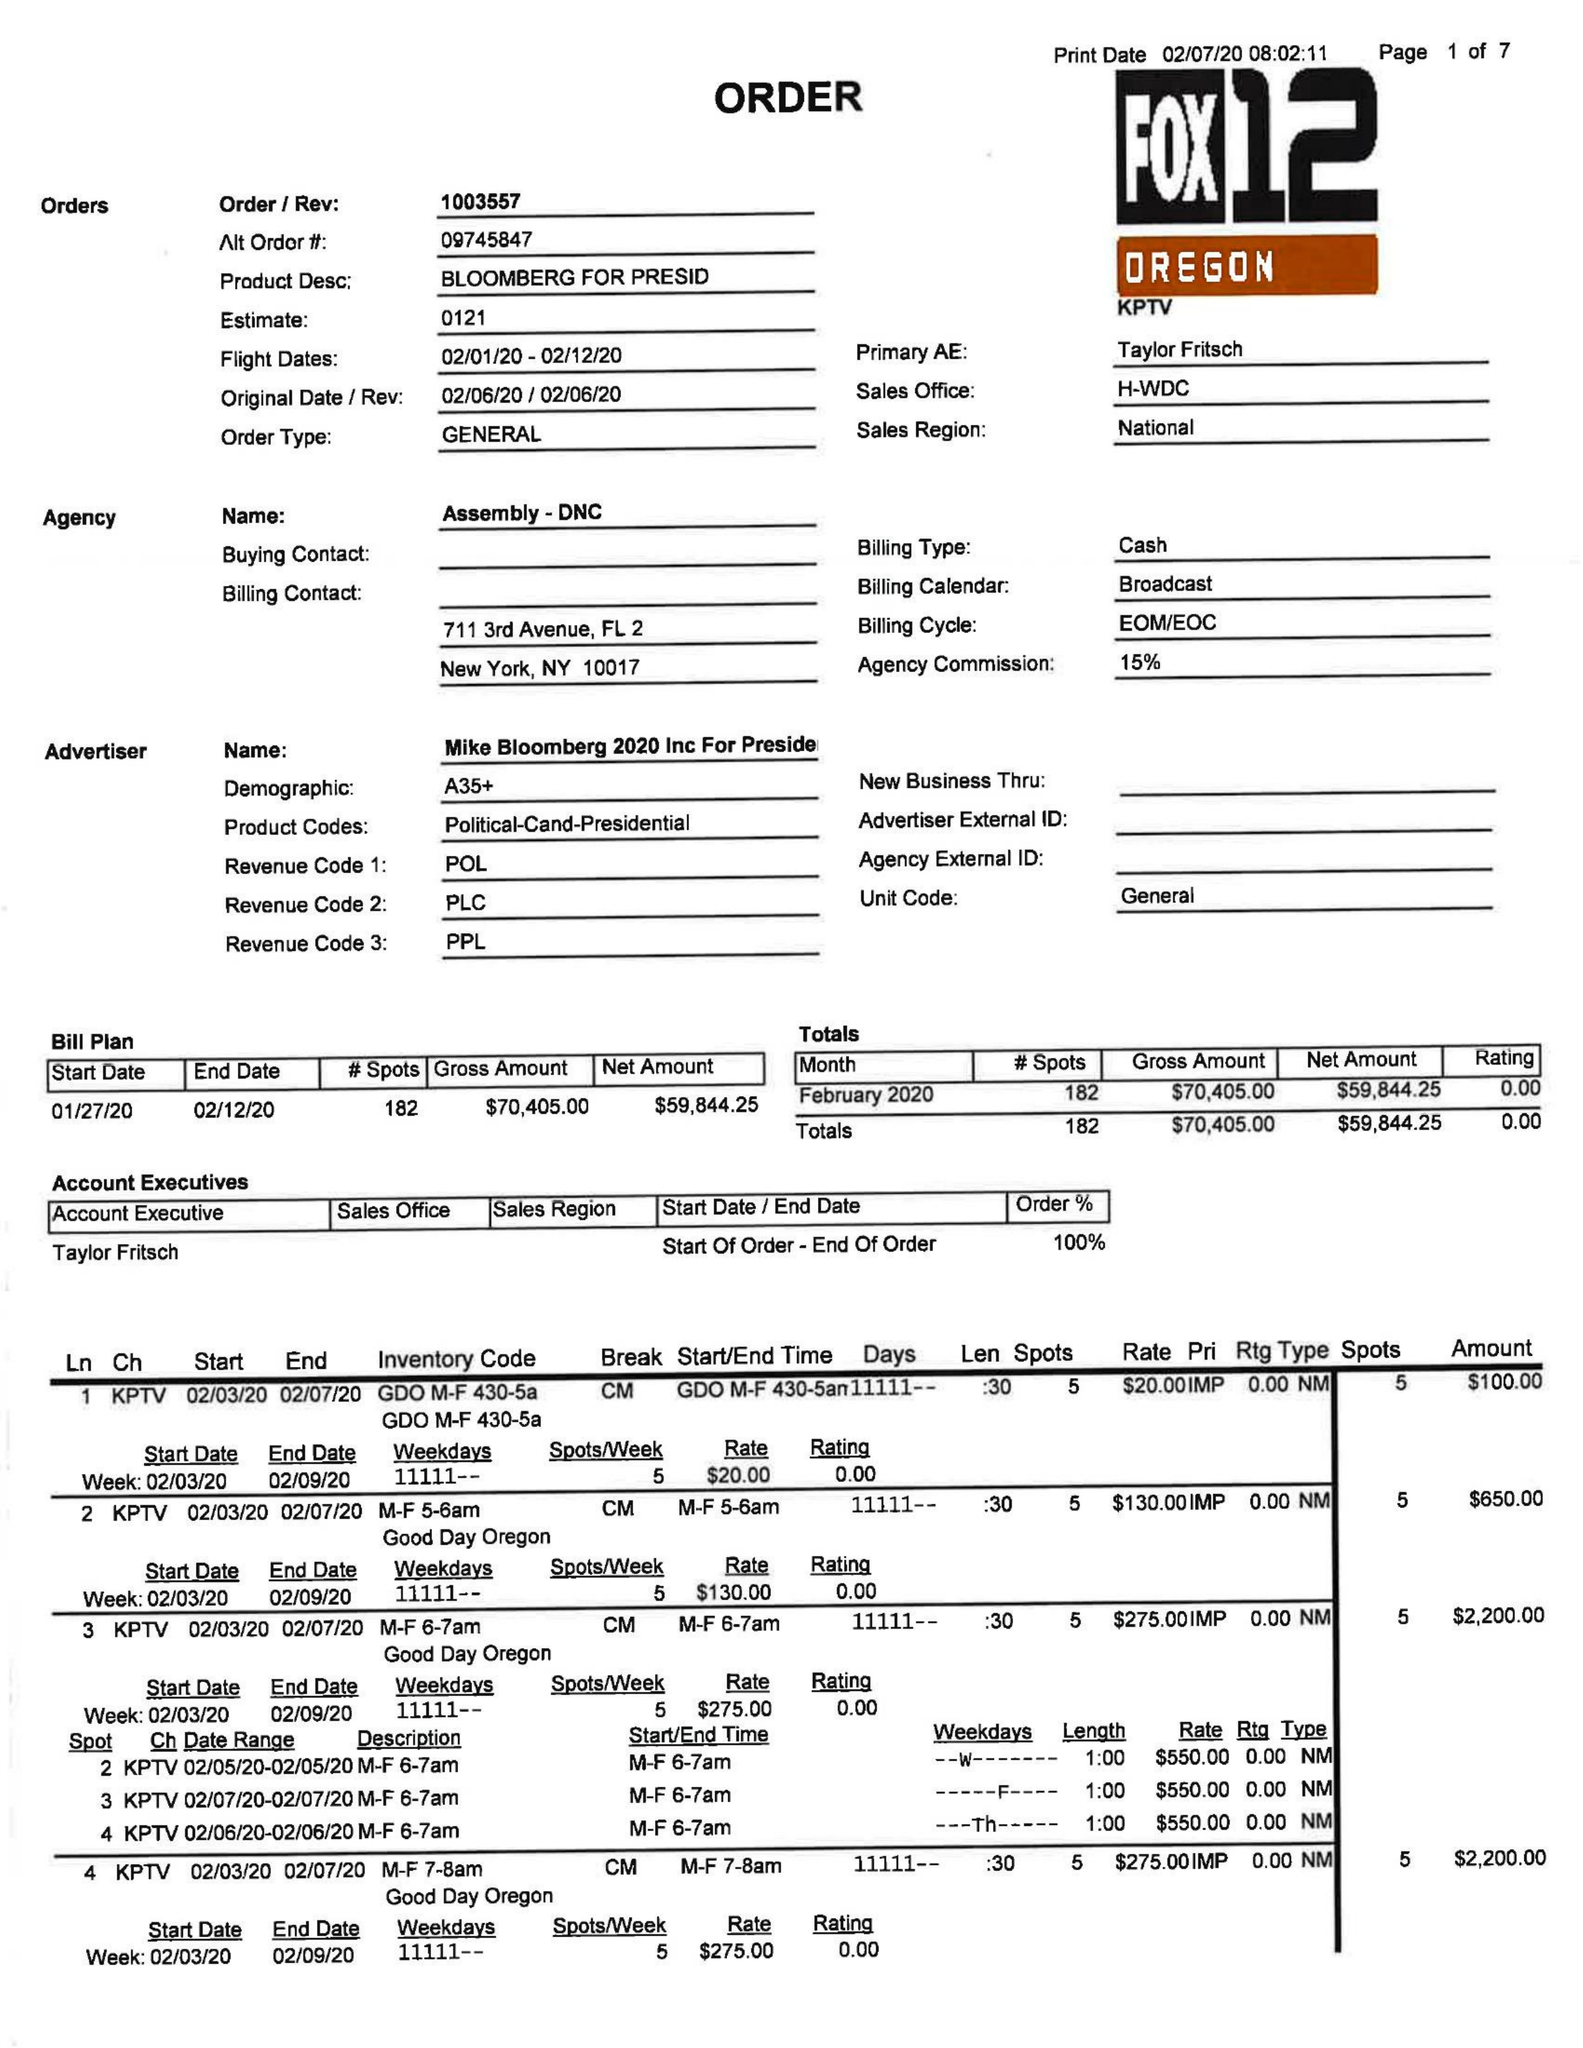What is the value for the gross_amount?
Answer the question using a single word or phrase. 70405.00 